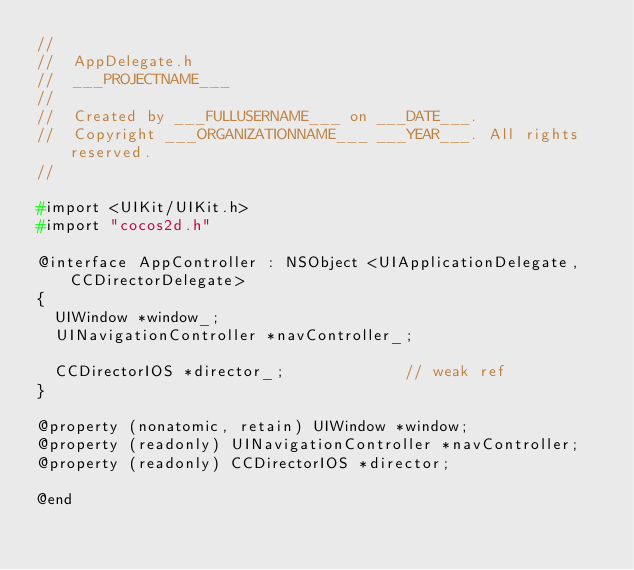Convert code to text. <code><loc_0><loc_0><loc_500><loc_500><_C_>//
//  AppDelegate.h
//  ___PROJECTNAME___
//
//  Created by ___FULLUSERNAME___ on ___DATE___.
//  Copyright ___ORGANIZATIONNAME___ ___YEAR___. All rights reserved.
//

#import <UIKit/UIKit.h>
#import "cocos2d.h"

@interface AppController : NSObject <UIApplicationDelegate, CCDirectorDelegate>
{
	UIWindow *window_;
	UINavigationController *navController_;
	
	CCDirectorIOS	*director_;							// weak ref
}

@property (nonatomic, retain) UIWindow *window;
@property (readonly) UINavigationController *navController;
@property (readonly) CCDirectorIOS *director;

@end
</code> 